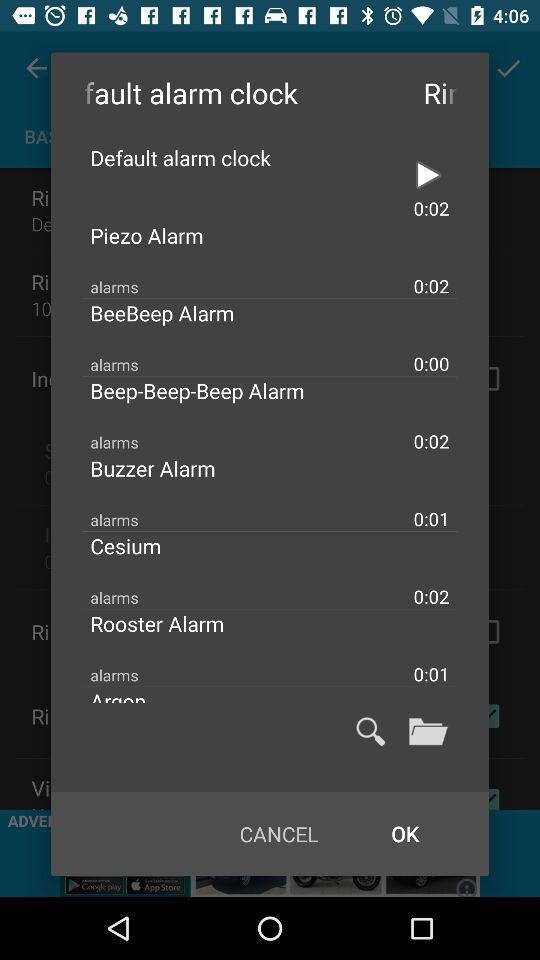What alarm clock tone was played? The alarm clock tone played was "Default alarm clock". 